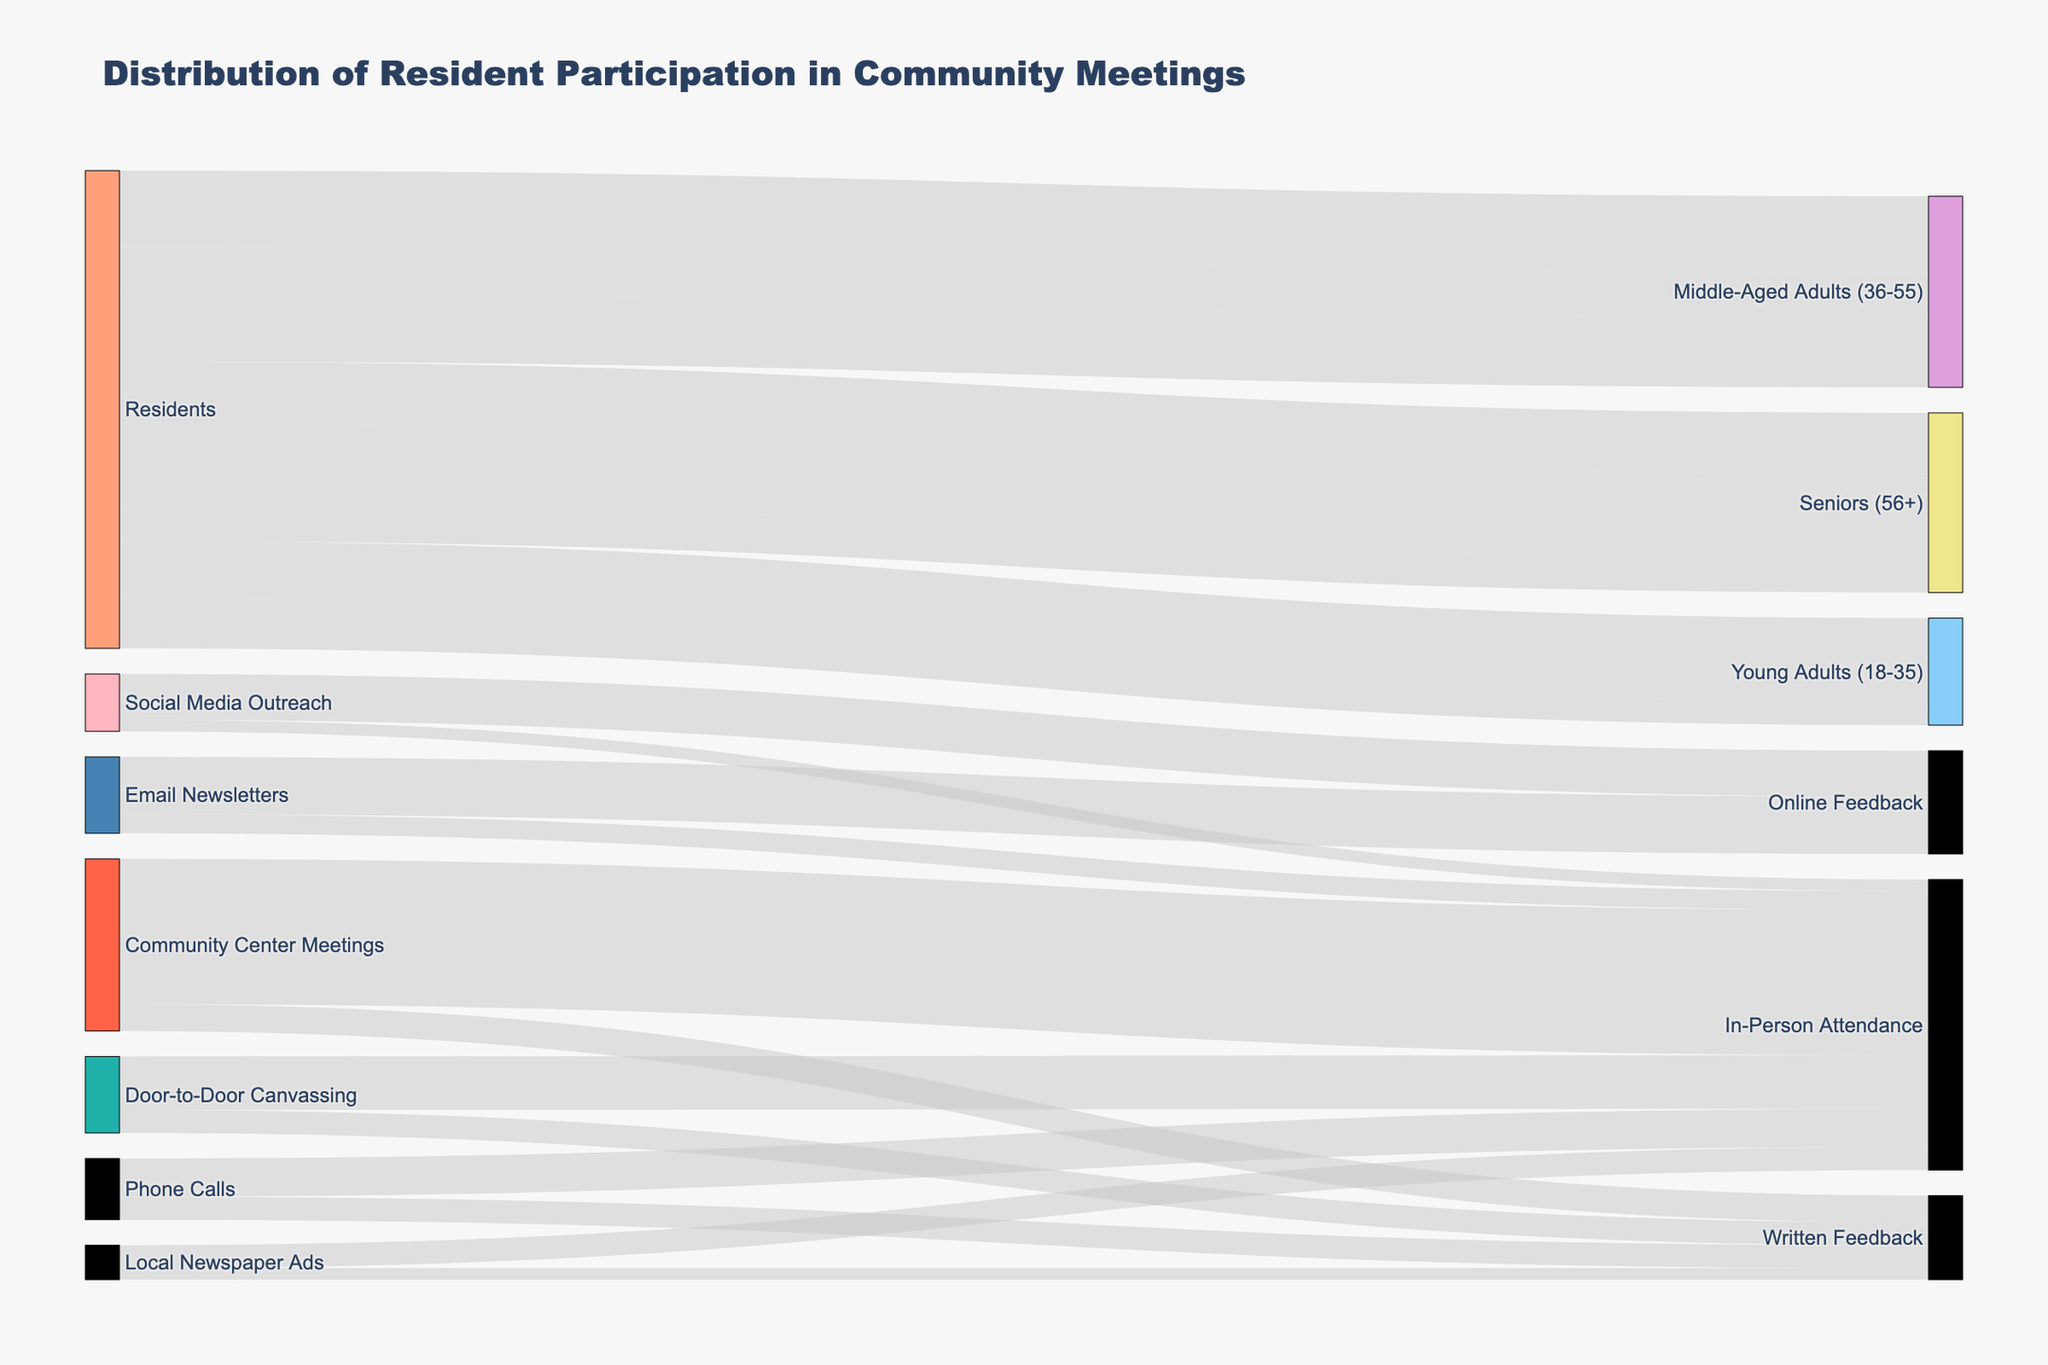What's the title of the figure? The title is usually placed prominently at the top of the figure and describes the content being illustrated. In this case, the title text is clearly defined in the diagram context.
Answer: Distribution of Resident Participation in Community Meetings Which demographic group has the highest participation in Community Center Meetings? To find this, look at the segment of the diagram that connects demographics to Community Center Meetings. The demographic with the largest connection value is the one with the highest participation.
Answer: Seniors (56+) How many total participants were there from Door-to-Door Canvassing? Add the participants from all demographic groups connected to Door-to-Door Canvassing. From the data: Young Adults (18-35) = 80, Middle-Aged Adults (36-55) = 120. Summing these gives the total.
Answer: 200 Which demographic had the least total participants across all engagement methods? Sum the participants for each demographic across all methods, then compare sums. For Young Adults (18-35): 150 + 80 + 50 = 280. For Middle-Aged Adults (36-55): 200 + 120 + 180 = 500. For Seniors (56+): 160 + 220 + 90 = 470. Young Adults have the least total participants with 280.
Answer: Young Adults (18-35) How many participants provided written feedback from all engagement methods combined? Identify all segments reaching "Written Feedback": Door-to-Door Canvassing = 60, Community Center Meetings = 70, Phone Calls = 60, Local Newspaper Ads = 30. Add these up.
Answer: 220 Compare the number of participants who attended in-person via Email Newsletters and Social Media Outreach. Which method had more participants? Look at the segments connecting Email Newsletters and Social Media Outreach to In-Person Attendance. Compare the values. Email Newsletters has 50 and Social Media Outreach has 30.
Answer: Email Newsletters What is the total number of participants who engaged through Phone Calls? Sum the participants connected to Phone Calls from the demographic segment. From the data, Phone Calls = 160.
Answer: 160 How many more participants attended in-person Community Center Meetings compared to in-person Social Media Outreach? Find the values for in-person attendance from each method, then subtract. Community Center Meetings = 380, Social Media Outreach = 30. So, 380 - 30 = 350.
Answer: 350 Which method had the highest number of participants giving online feedback? Examine segments that include online feedback, observing the associated values, then identify the maximum. Email Newsletters has 150, Social Media Outreach has 120. Thus, Email Newsletters has the highest value.
Answer: Email Newsletters 